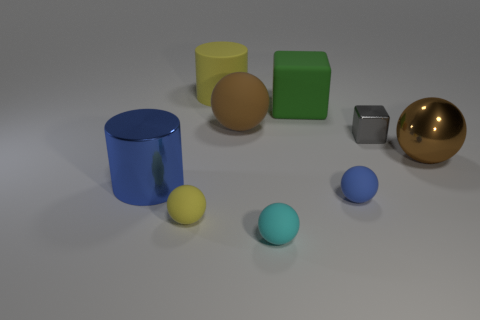Is there a matte thing that has the same color as the rubber cylinder?
Provide a short and direct response. Yes. How many other things are the same shape as the big blue thing?
Your response must be concise. 1. What is the shape of the thing that is to the right of the gray cube?
Your response must be concise. Sphere. There is a large brown metallic thing; does it have the same shape as the blue object on the right side of the tiny cyan ball?
Offer a terse response. Yes. There is a thing that is on the left side of the gray object and on the right side of the green block; how big is it?
Offer a very short reply. Small. There is a object that is both behind the small yellow rubber ball and to the left of the big yellow matte object; what is its color?
Keep it short and to the point. Blue. Is the number of balls that are behind the yellow sphere less than the number of large things on the left side of the gray thing?
Keep it short and to the point. Yes. Are there any other things that have the same color as the metal cylinder?
Give a very brief answer. Yes. The big yellow object has what shape?
Keep it short and to the point. Cylinder. The big cube that is made of the same material as the cyan object is what color?
Offer a terse response. Green. 